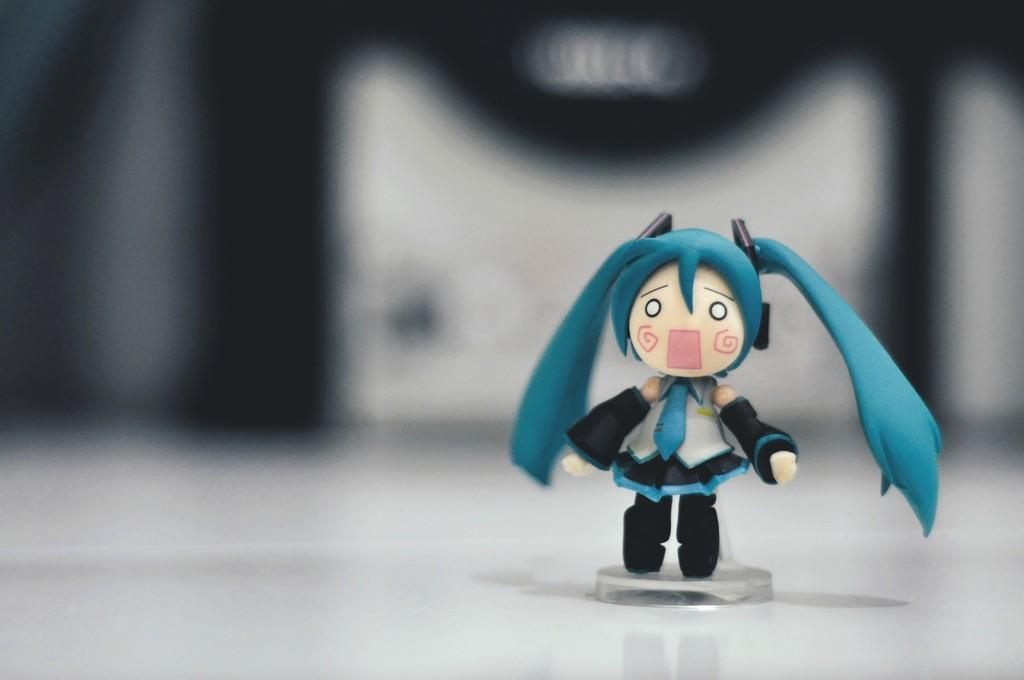Describe this image in one or two sentences. In this image I can see a toy which is in white,blue and white color. Background is in black and white color. 